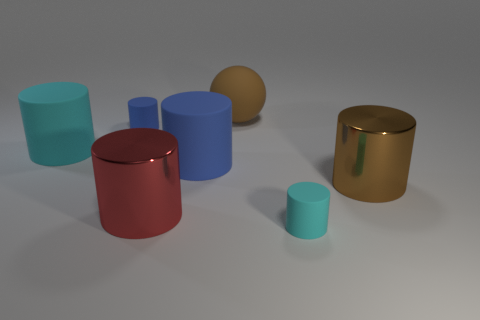There is a large cylinder that is right of the large red metallic cylinder and behind the brown metal thing; what is its material?
Provide a short and direct response. Rubber. Are there any red things of the same size as the brown sphere?
Keep it short and to the point. Yes. How many yellow cylinders are there?
Offer a terse response. 0. How many big brown matte balls are in front of the small cyan object?
Keep it short and to the point. 0. Is the material of the tiny blue cylinder the same as the large red object?
Make the answer very short. No. What number of tiny objects are to the left of the rubber sphere and in front of the red metallic cylinder?
Your response must be concise. 0. What number of other objects are there of the same color as the ball?
Your response must be concise. 1. What number of purple things are either spheres or small cylinders?
Offer a very short reply. 0. What size is the red cylinder?
Provide a succinct answer. Large. What number of shiny things are either large blue cylinders or purple things?
Offer a very short reply. 0. 